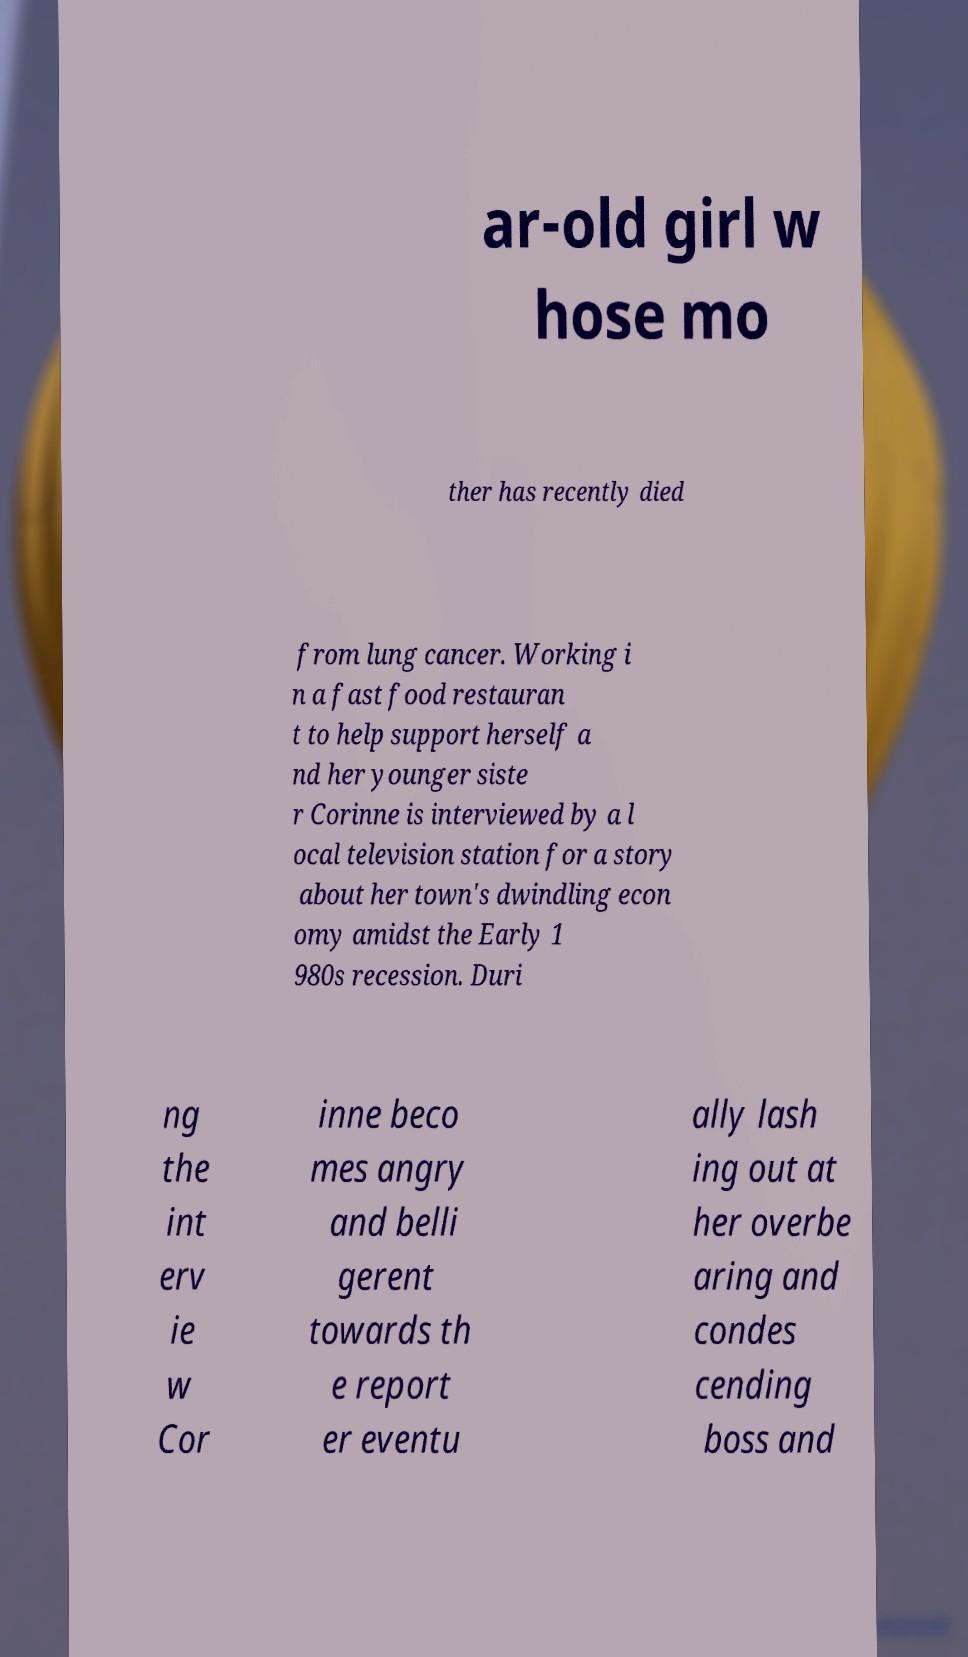Can you accurately transcribe the text from the provided image for me? ar-old girl w hose mo ther has recently died from lung cancer. Working i n a fast food restauran t to help support herself a nd her younger siste r Corinne is interviewed by a l ocal television station for a story about her town's dwindling econ omy amidst the Early 1 980s recession. Duri ng the int erv ie w Cor inne beco mes angry and belli gerent towards th e report er eventu ally lash ing out at her overbe aring and condes cending boss and 